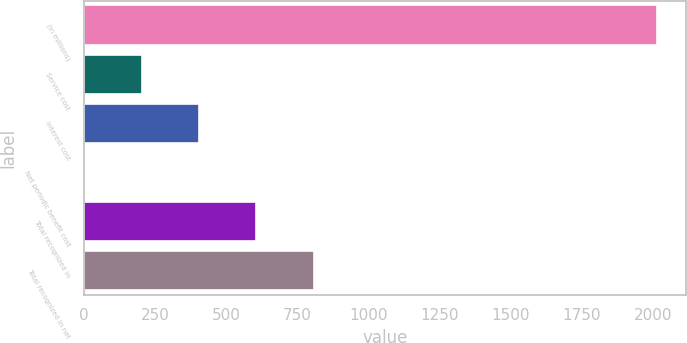Convert chart to OTSL. <chart><loc_0><loc_0><loc_500><loc_500><bar_chart><fcel>(in millions)<fcel>Service cost<fcel>Interest cost<fcel>Net periodic benefit cost<fcel>Total recognized in<fcel>Total recognized in net<nl><fcel>2014<fcel>203.2<fcel>404.4<fcel>2<fcel>605.6<fcel>806.8<nl></chart> 